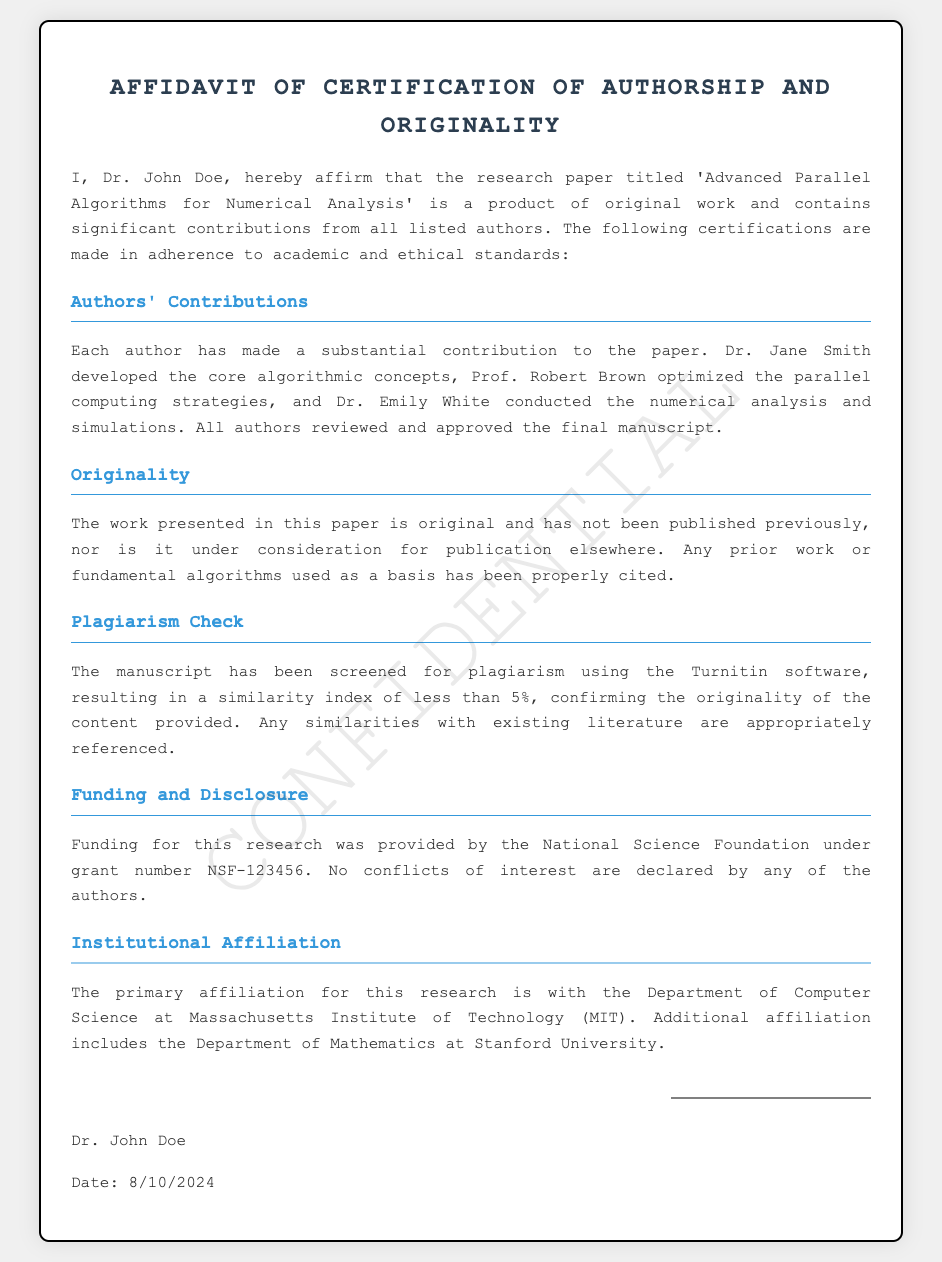What is the title of the research paper? The title of the research paper is stated prominently in the document, which is 'Advanced Parallel Algorithms for Numerical Analysis'.
Answer: Advanced Parallel Algorithms for Numerical Analysis Who is the first author? The first author is mentioned at the beginning of the affidavit, which is Dr. John Doe.
Answer: Dr. John Doe What percentage was the similarity index from the plagiarism check? The document explicitly states the similarity index from the plagiarism check as less than 5%.
Answer: less than 5% What funding agency supported this research? The affidavit mentions that the funding for this research was provided by the National Science Foundation.
Answer: National Science Foundation Which department is Dr. John Doe affiliated with? It is indicated that Dr. John Doe is affiliated with the Department of Computer Science at Massachusetts Institute of Technology (MIT).
Answer: Department of Computer Science at Massachusetts Institute of Technology What significant contribution did Prof. Robert Brown make? Prof. Robert Brown's contribution is specifically stated as optimizing the parallel computing strategies.
Answer: Optimized the parallel computing strategies How many authors are listed in the document? The document mentions contributions from three authors who are all listed: Dr. Jane Smith, Prof. Robert Brown, and Dr. Emily White, implying a total of three authors.
Answer: Three What software was used for the plagiarism check? The affidavit specifically mentions that the manuscript was screened for plagiarism using Turnitin software.
Answer: Turnitin What type of document is this? The document type is specified in the title and throughout as an Affidavit of Certification of Authorship and Originality.
Answer: Affidavit of Certification of Authorship and Originality 